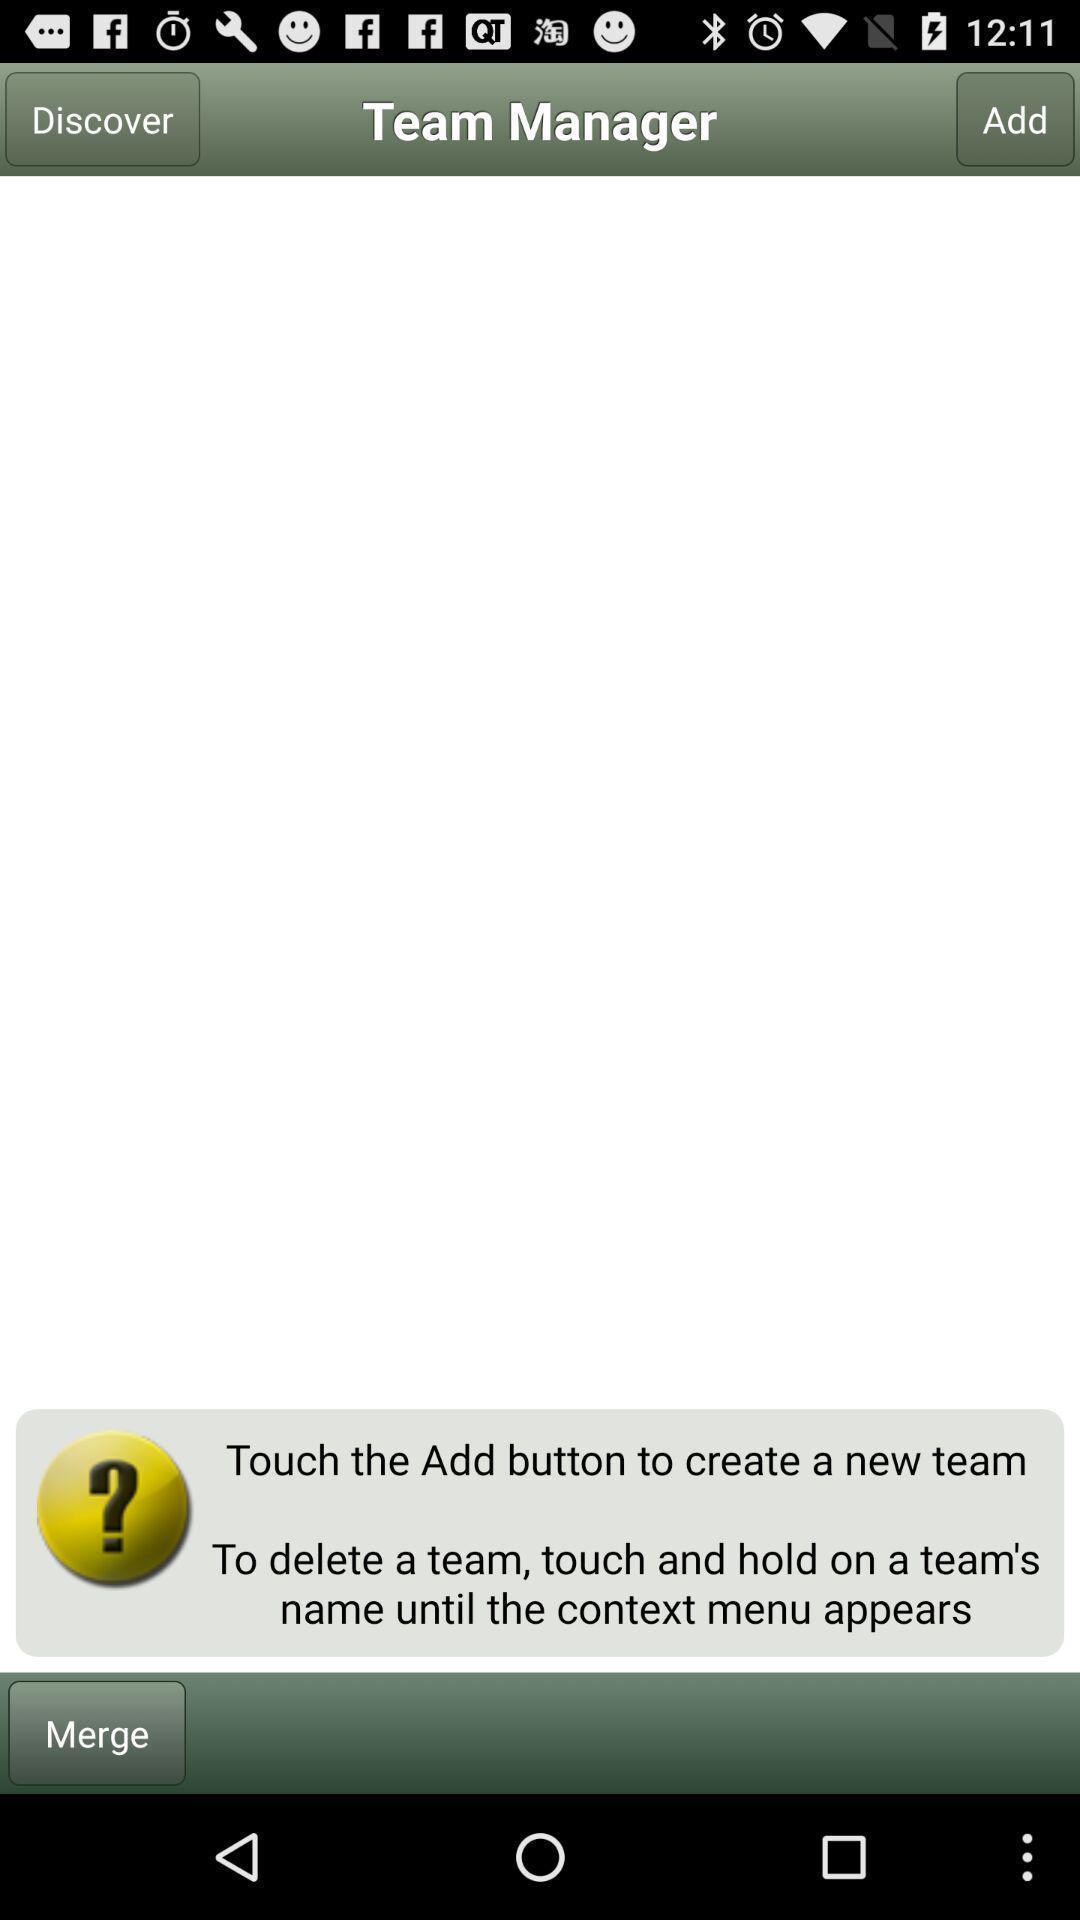What is the overall content of this screenshot? Screen displays general information of team manager app. 